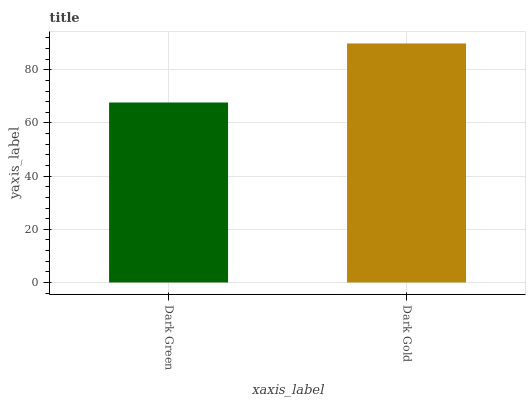Is Dark Green the minimum?
Answer yes or no. Yes. Is Dark Gold the maximum?
Answer yes or no. Yes. Is Dark Gold the minimum?
Answer yes or no. No. Is Dark Gold greater than Dark Green?
Answer yes or no. Yes. Is Dark Green less than Dark Gold?
Answer yes or no. Yes. Is Dark Green greater than Dark Gold?
Answer yes or no. No. Is Dark Gold less than Dark Green?
Answer yes or no. No. Is Dark Gold the high median?
Answer yes or no. Yes. Is Dark Green the low median?
Answer yes or no. Yes. Is Dark Green the high median?
Answer yes or no. No. Is Dark Gold the low median?
Answer yes or no. No. 